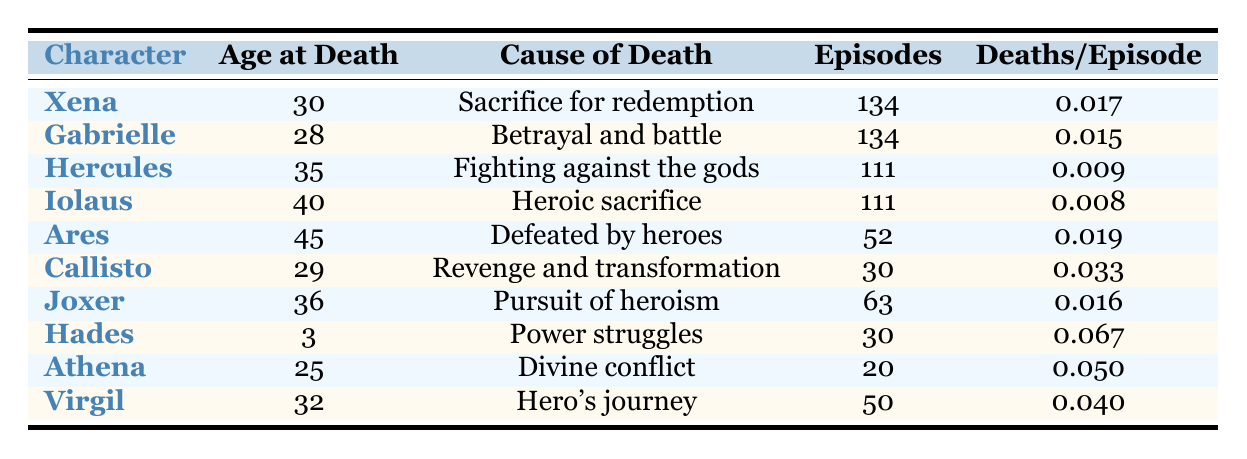What is the age at death for Xena? The table shows that Xena's age at death is listed in the second column under "Age at Death." It states that Xena died at the age of 30.
Answer: 30 What caused Gabrielle's death? The table lists the cause of death for each character in the "Cause of Death" column. For Gabrielle, it is noted that her cause of death was "Betrayal and battle."
Answer: Betrayal and battle Which character had the highest deaths per episode? By comparing the values in the "Deaths/Episode" column, we look for the highest value. Hades is shown to have a deaths per episode rate of 0.067, which is the largest among all characters.
Answer: Hades What is the average age at death of the characters listed? To find the average age, we first sum the ages at death for all characters: 30 + 28 + 35 + 40 + 45 + 29 + 36 + 3 + 25 + 32 = 303. There are 10 characters, so we divide: 303 / 10 = 30.3.
Answer: 30.3 Is the cause of death for Ares related to interactions with heroes? The "Cause of Death" for Ares is listed as "Defeated by heroes," indicating that his death is indeed related to interactions with heroes.
Answer: Yes Which character featured in the largest number of episodes? By examining the "Episodes" column, we find the values for each character. Xena and Gabrielle both featured in 134 episodes, which is the highest count.
Answer: Xena and Gabrielle What is the total number of episodes across all characters? We sum the episodes featured by each character: 134 + 134 + 111 + 111 + 52 + 30 + 63 + 30 + 20 + 50 =  134 + 134 = 268; 268 + 111 = 379; 379 + 111 = 490; 490 + 52 = 542; 542 + 30 = 572; 572 + 63 = 635; 635 + 30 = 665; 665 + 20 = 685; 685 + 50 = 735. The total is 735 episodes.
Answer: 735 Is Callisto older than Xena at the time of death? The ages at death are given as 29 for Callisto and 30 for Xena, thus Callisto is not older than Xena, as 29 is less than 30.
Answer: No Which character had the cause of death that does not involve any form of battle? By reviewing the "Cause of Death" column, the only listed cause that does not mention battle in some form is Hades with "Power struggles."
Answer: Hades 